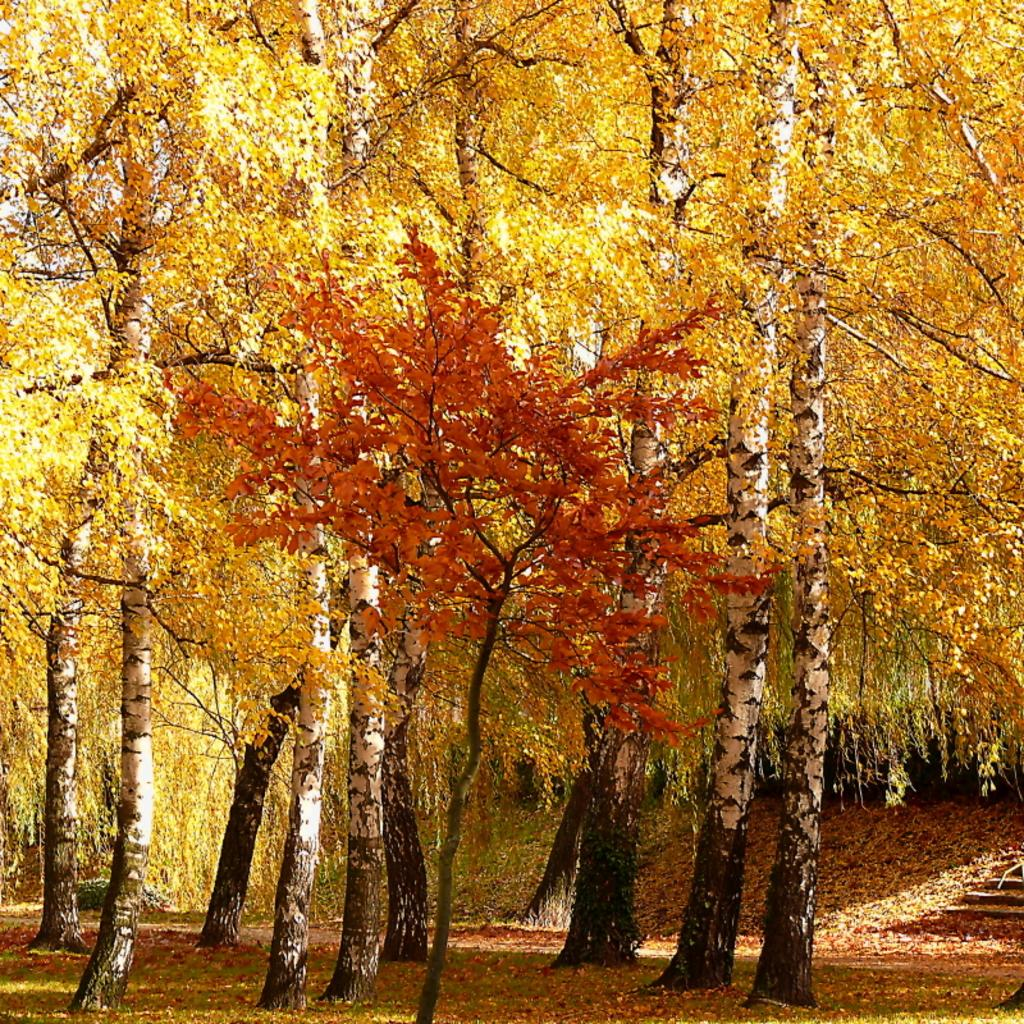What is the main subject of the image? The main subject of the image is many trees. What can be observed about the leaves of the trees? The leaves of the trees are in yellow and orange colors. What type of wine is being served by the queen on the rock in the image? There is no wine, queen, or rock present in the image; it features many trees with yellow and orange leaves. 